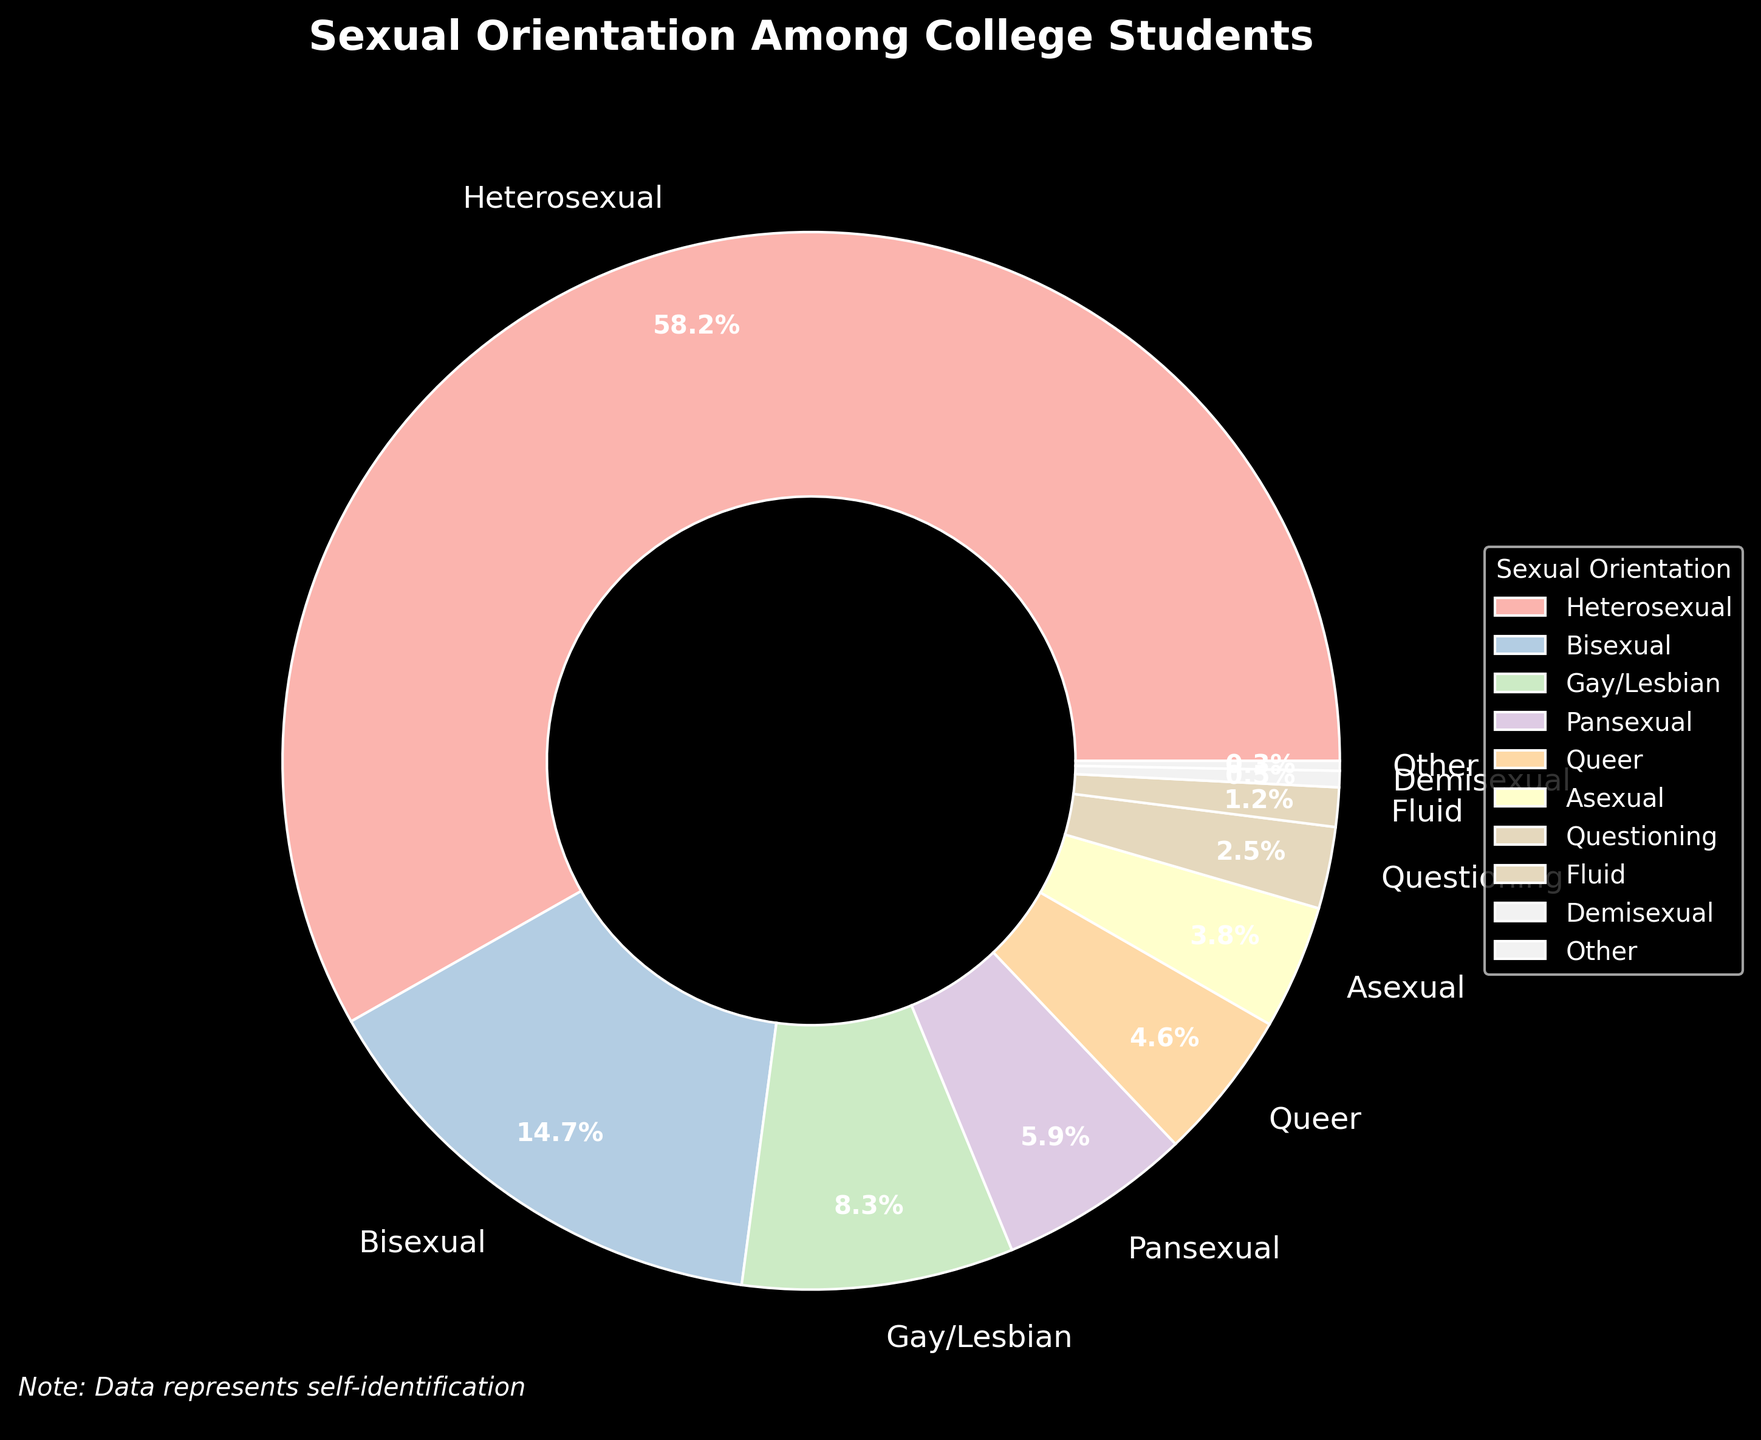Which sexual orientation has the largest percentage among college students? The pie chart shows the percentage breakdown of different sexual orientations. Heterosexual has the largest portion of the chart.
Answer: Heterosexual What is the total percentage of students who identify as bisexual, pansexual, and queer combined? Add the percentages of students who identify as bisexual (14.7%), pansexual (5.9%), and queer (4.6%). The total is 14.7 + 5.9 + 4.6 = 25.2%
Answer: 25.2% How does the percentage of students identifying as gay/lesbian compare to those identifying as bisexual? The figure shows 8.3% for gay/lesbian and 14.7% for bisexual. Compare these percentages: 14.7% is greater than 8.3%.
Answer: Bisexual is greater What is the difference in percentage between heterosexual and asexual students? Subtract the percentage of asexual students (3.8%) from the percentage of heterosexual students (58.2%). The difference is 58.2 - 3.8 = 54.4%
Answer: 54.4% Which sexual orientation category represents the smallest portion of the college student population? Identify the smallest wedge in the pie chart, which corresponds to the "Other" category at 0.3%.
Answer: Other Do students who identify as questioning or fluid combined make up more than 3% of the population? Add the percentages for questioning (2.5%) and fluid (1.2%). The combined percentage is 2.5 + 1.2 = 3.7%, which is more than 3%.
Answer: Yes What is the percentage difference between students identifying as pansexual and queer? Subtract the percentage of queer students (4.6%) from the percentage of pansexual students (5.9%). The difference is 5.9 - 4.6 = 1.3%
Answer: 1.3% Is the percentage of students who identify as demisexual larger than those identifying as fluid? Compare the percentages of demisexual (0.5%) and fluid (1.2%). 1.2% is larger than 0.5%.
Answer: No What's the average percentage of students identifying in the top three categories? Calculate the average of the top three percentages: heterosexual (58.2%), bisexual (14.7%), and gay/lesbian (8.3%). The average is (58.2 + 14.7 + 8.3) / 3 = 27.07%
Answer: 27.07% Which orientations have a percentage greater than 4% but less than 10%? Examine the pie chart for orientations within this range: bisexual (14.7%), gay/lesbian (8.3%), pansexual (5.9%), and queer (4.6%) are considered. Only gay/lesbian, pansexual, and queer fit the criteria.
Answer: Gay/lesbian, pansexual, queer 